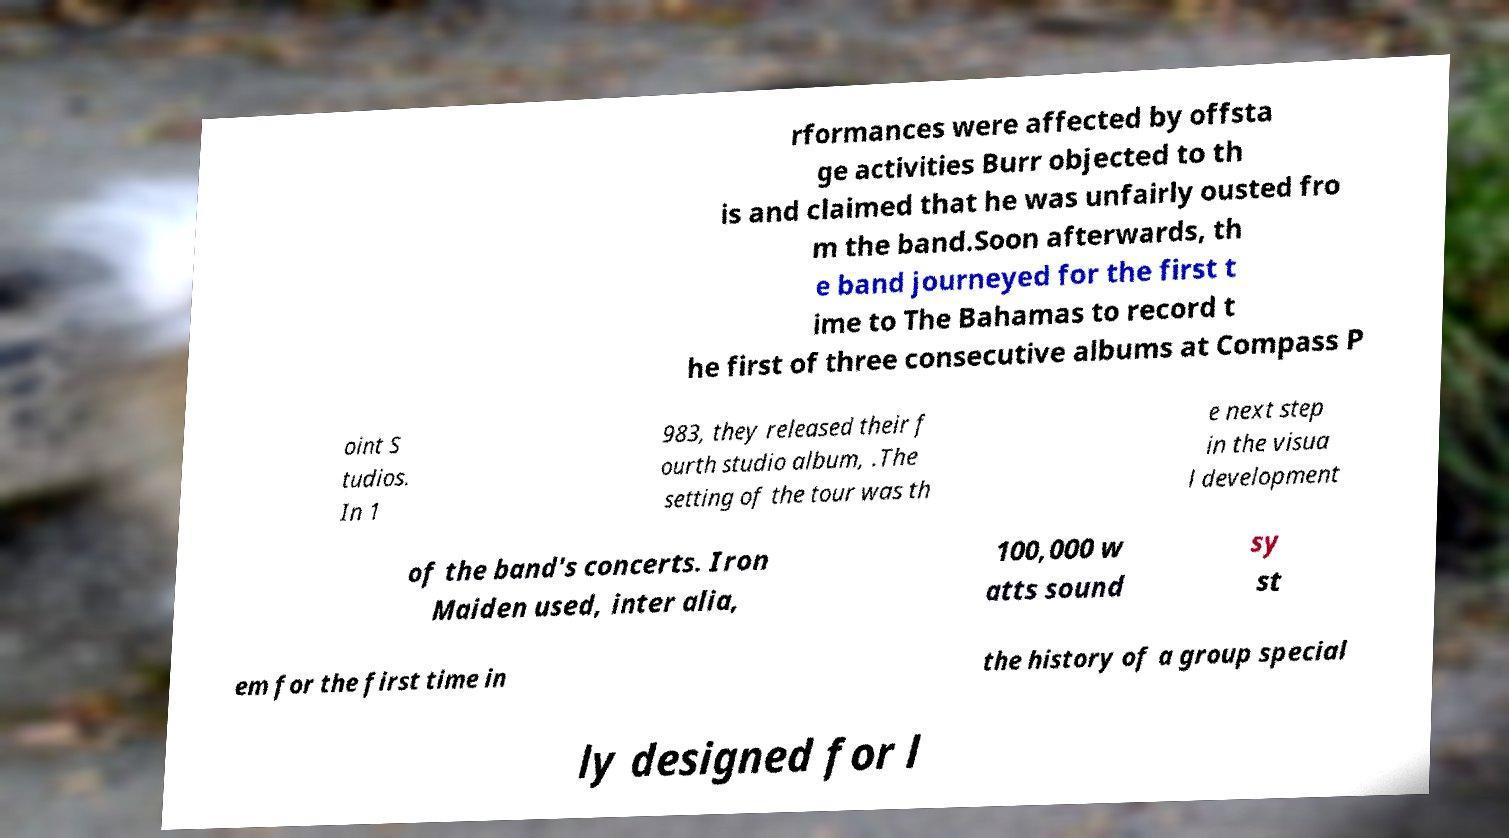I need the written content from this picture converted into text. Can you do that? rformances were affected by offsta ge activities Burr objected to th is and claimed that he was unfairly ousted fro m the band.Soon afterwards, th e band journeyed for the first t ime to The Bahamas to record t he first of three consecutive albums at Compass P oint S tudios. In 1 983, they released their f ourth studio album, .The setting of the tour was th e next step in the visua l development of the band's concerts. Iron Maiden used, inter alia, 100,000 w atts sound sy st em for the first time in the history of a group special ly designed for l 